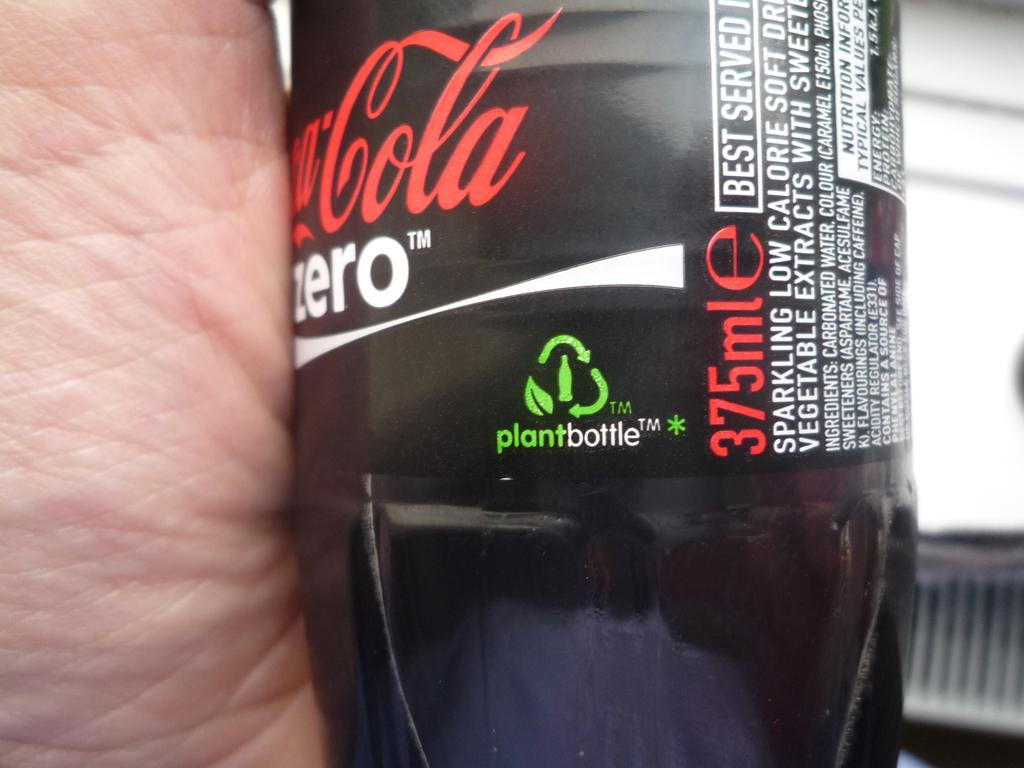What color is the bottle that is visible in the image? There is a black bottle in the image. What is written on the black bottle? There is writing on the black bottle. What type of silver net can be seen surrounding the black bottle in the image? There is no silver net present in the image; it only features a black bottle with writing on it. 